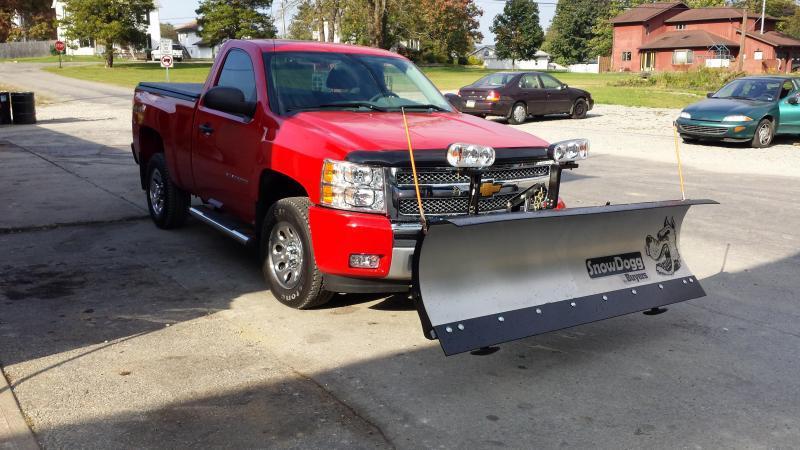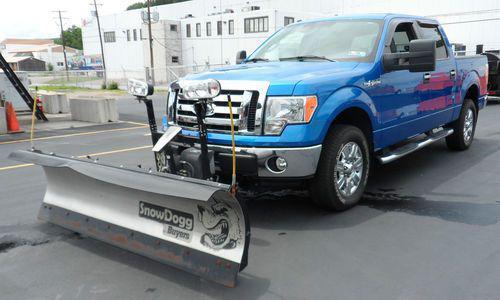The first image is the image on the left, the second image is the image on the right. Assess this claim about the two images: "At least one of the plows is made up of two separate panels with a gap between them.". Correct or not? Answer yes or no. No. The first image is the image on the left, the second image is the image on the right. Considering the images on both sides, is "A truck is red." valid? Answer yes or no. Yes. 